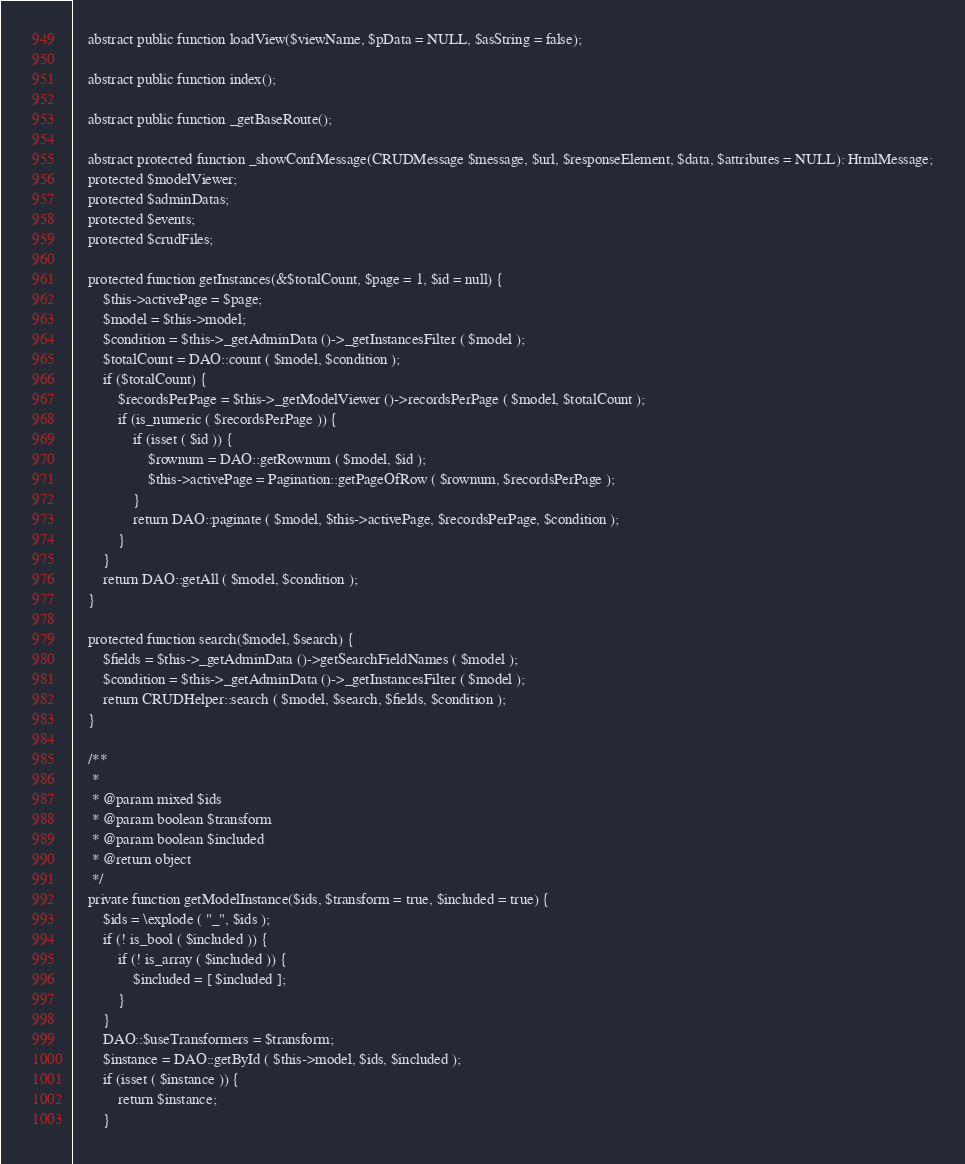<code> <loc_0><loc_0><loc_500><loc_500><_PHP_>
	abstract public function loadView($viewName, $pData = NULL, $asString = false);

	abstract public function index();

	abstract public function _getBaseRoute();

	abstract protected function _showConfMessage(CRUDMessage $message, $url, $responseElement, $data, $attributes = NULL): HtmlMessage;
	protected $modelViewer;
	protected $adminDatas;
	protected $events;
	protected $crudFiles;

	protected function getInstances(&$totalCount, $page = 1, $id = null) {
		$this->activePage = $page;
		$model = $this->model;
		$condition = $this->_getAdminData ()->_getInstancesFilter ( $model );
		$totalCount = DAO::count ( $model, $condition );
		if ($totalCount) {
			$recordsPerPage = $this->_getModelViewer ()->recordsPerPage ( $model, $totalCount );
			if (is_numeric ( $recordsPerPage )) {
				if (isset ( $id )) {
					$rownum = DAO::getRownum ( $model, $id );
					$this->activePage = Pagination::getPageOfRow ( $rownum, $recordsPerPage );
				}
				return DAO::paginate ( $model, $this->activePage, $recordsPerPage, $condition );
			}
		}
		return DAO::getAll ( $model, $condition );
	}

	protected function search($model, $search) {
		$fields = $this->_getAdminData ()->getSearchFieldNames ( $model );
		$condition = $this->_getAdminData ()->_getInstancesFilter ( $model );
		return CRUDHelper::search ( $model, $search, $fields, $condition );
	}

	/**
	 *
	 * @param mixed $ids
	 * @param boolean $transform
	 * @param boolean $included
	 * @return object
	 */
	private function getModelInstance($ids, $transform = true, $included = true) {
		$ids = \explode ( "_", $ids );
		if (! is_bool ( $included )) {
			if (! is_array ( $included )) {
				$included = [ $included ];
			}
		}
		DAO::$useTransformers = $transform;
		$instance = DAO::getById ( $this->model, $ids, $included );
		if (isset ( $instance )) {
			return $instance;
		}</code> 